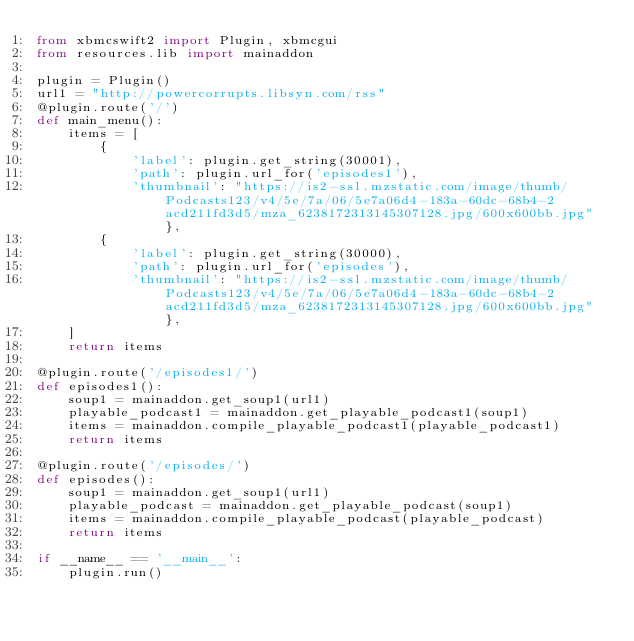Convert code to text. <code><loc_0><loc_0><loc_500><loc_500><_Python_>from xbmcswift2 import Plugin, xbmcgui
from resources.lib import mainaddon

plugin = Plugin()
url1 = "http://powercorrupts.libsyn.com/rss"
@plugin.route('/')
def main_menu():
    items = [
        {
            'label': plugin.get_string(30001), 
            'path': plugin.url_for('episodes1'),
            'thumbnail': "https://is2-ssl.mzstatic.com/image/thumb/Podcasts123/v4/5e/7a/06/5e7a06d4-183a-60dc-68b4-2acd211fd3d5/mza_6238172313145307128.jpg/600x600bb.jpg"},
        {
            'label': plugin.get_string(30000),
            'path': plugin.url_for('episodes'),
            'thumbnail': "https://is2-ssl.mzstatic.com/image/thumb/Podcasts123/v4/5e/7a/06/5e7a06d4-183a-60dc-68b4-2acd211fd3d5/mza_6238172313145307128.jpg/600x600bb.jpg"},
    ]
    return items

@plugin.route('/episodes1/')
def episodes1():
    soup1 = mainaddon.get_soup1(url1)
    playable_podcast1 = mainaddon.get_playable_podcast1(soup1)
    items = mainaddon.compile_playable_podcast1(playable_podcast1)
    return items

@plugin.route('/episodes/')
def episodes():
    soup1 = mainaddon.get_soup1(url1)
    playable_podcast = mainaddon.get_playable_podcast(soup1)
    items = mainaddon.compile_playable_podcast(playable_podcast)
    return items

if __name__ == '__main__':
    plugin.run()
</code> 